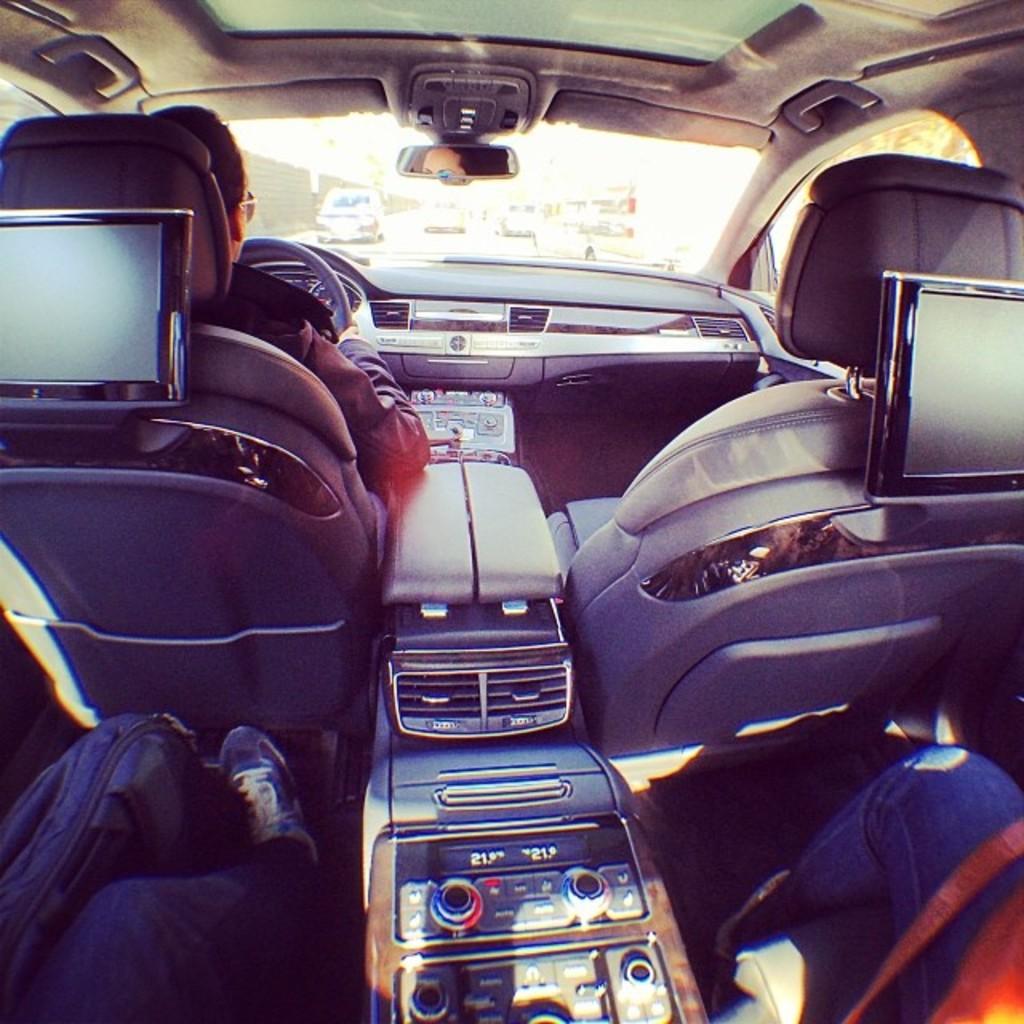Could you give a brief overview of what you see in this image? In this image I can see inside view of a vehicle and I can see three persons are sitting in it. In the centre I can see few buttons. On the bottom left side I can see a bag. I can also see two screens on the both sides of the image. In the background I can see a steering, a mirror and few other vehicles. 